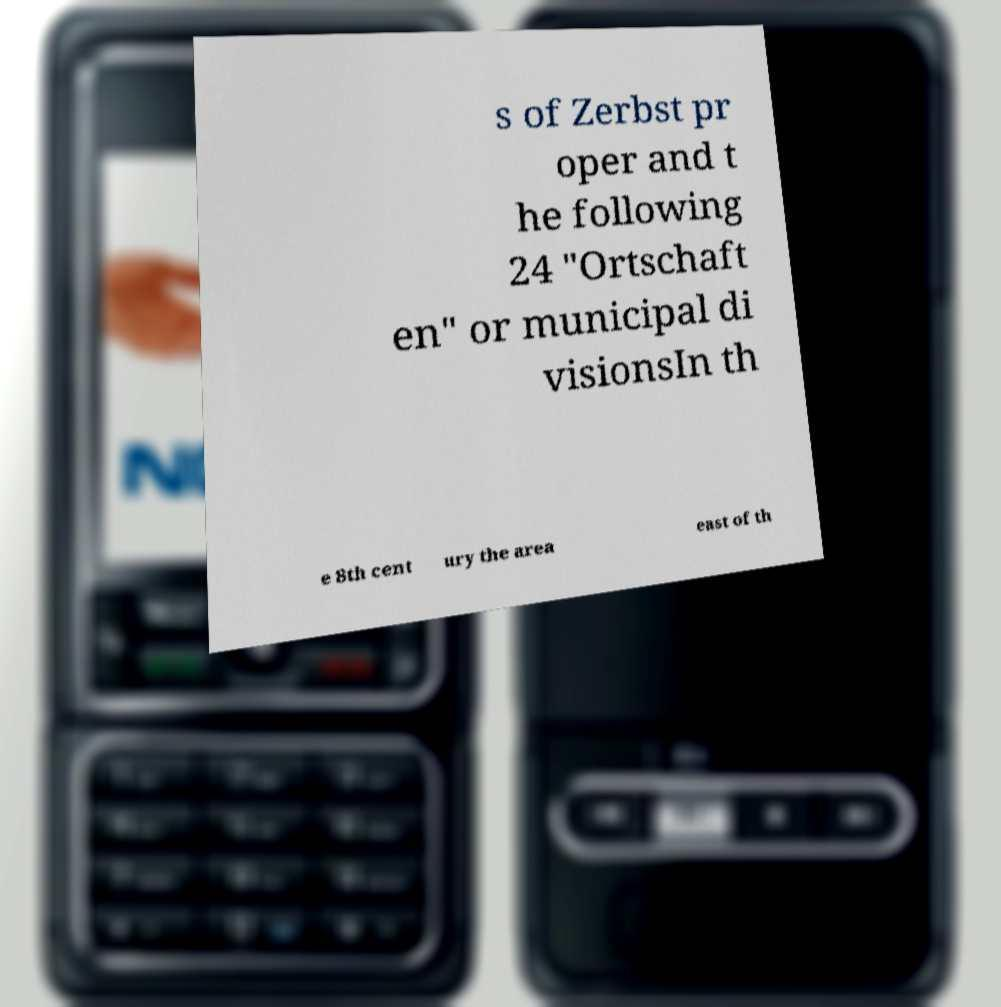Please read and relay the text visible in this image. What does it say? s of Zerbst pr oper and t he following 24 "Ortschaft en" or municipal di visionsIn th e 8th cent ury the area east of th 